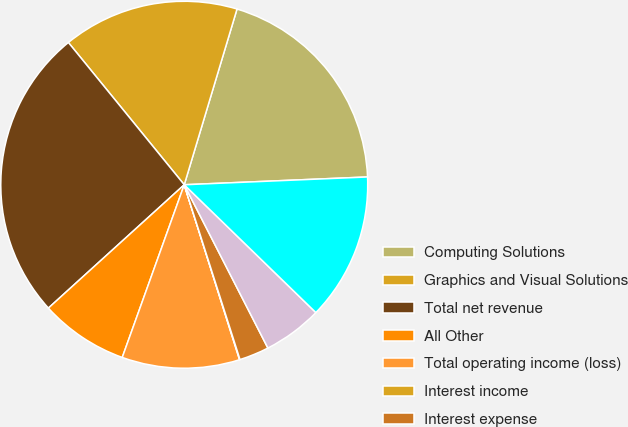Convert chart. <chart><loc_0><loc_0><loc_500><loc_500><pie_chart><fcel>Computing Solutions<fcel>Graphics and Visual Solutions<fcel>Total net revenue<fcel>All Other<fcel>Total operating income (loss)<fcel>Interest income<fcel>Interest expense<fcel>Other income (expense) net<fcel>Income (loss) from continuing<nl><fcel>19.68%<fcel>15.52%<fcel>25.85%<fcel>7.78%<fcel>10.36%<fcel>0.04%<fcel>2.62%<fcel>5.2%<fcel>12.94%<nl></chart> 